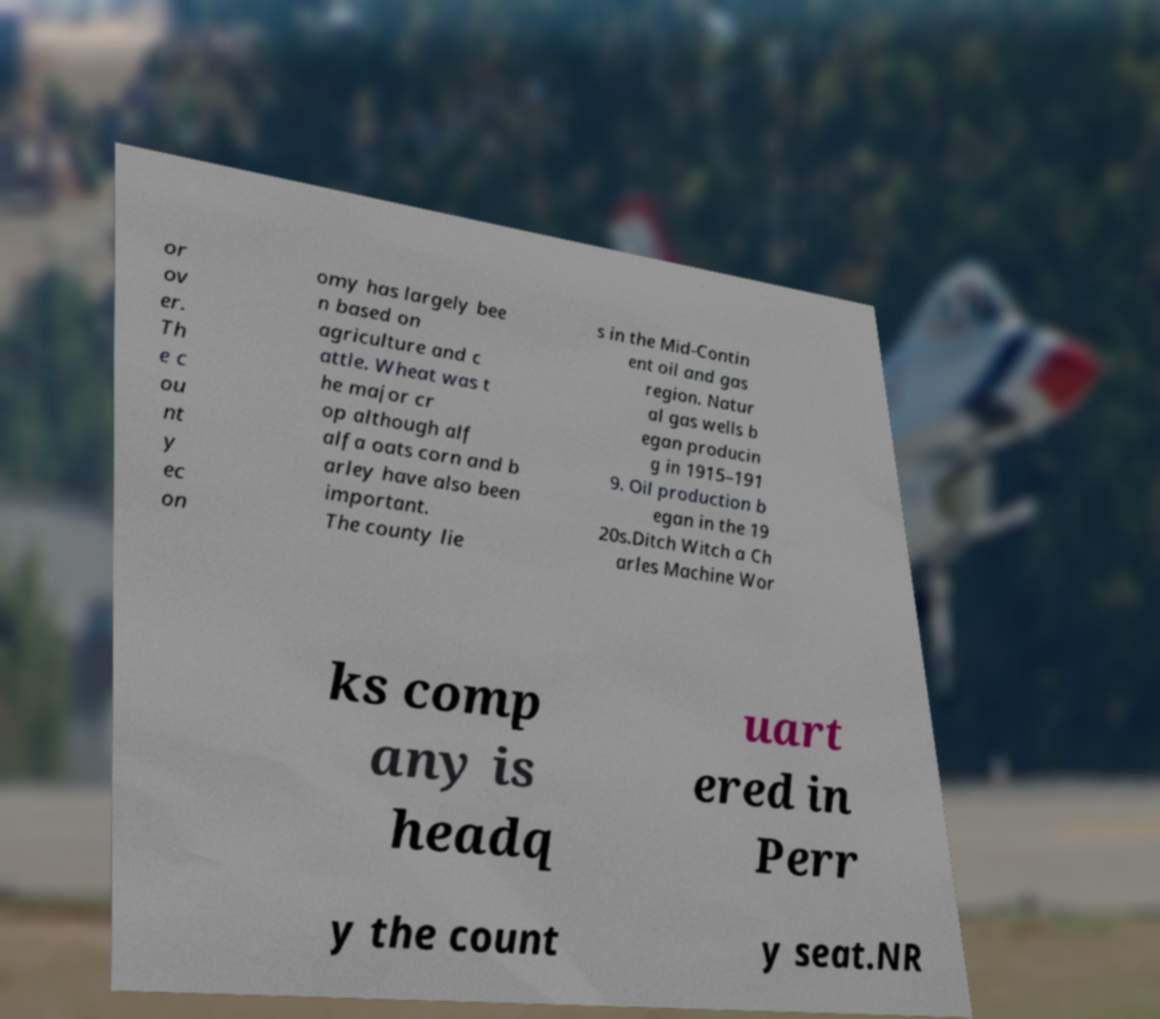Could you assist in decoding the text presented in this image and type it out clearly? or ov er. Th e c ou nt y ec on omy has largely bee n based on agriculture and c attle. Wheat was t he major cr op although alf alfa oats corn and b arley have also been important. The county lie s in the Mid-Contin ent oil and gas region. Natur al gas wells b egan producin g in 1915–191 9. Oil production b egan in the 19 20s.Ditch Witch a Ch arles Machine Wor ks comp any is headq uart ered in Perr y the count y seat.NR 